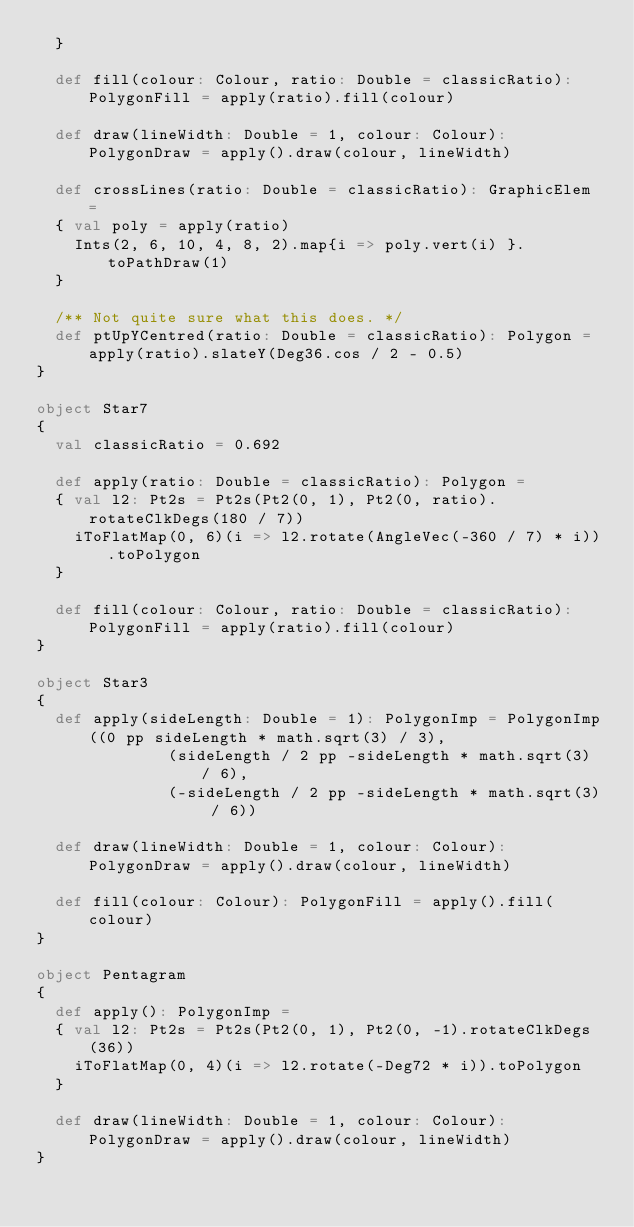<code> <loc_0><loc_0><loc_500><loc_500><_Scala_>  }

  def fill(colour: Colour, ratio: Double = classicRatio): PolygonFill = apply(ratio).fill(colour)
  
  def draw(lineWidth: Double = 1, colour: Colour): PolygonDraw = apply().draw(colour, lineWidth)

  def crossLines(ratio: Double = classicRatio): GraphicElem =
  { val poly = apply(ratio)
    Ints(2, 6, 10, 4, 8, 2).map{i => poly.vert(i) }.toPathDraw(1)
  }

  /** Not quite sure what this does. */
  def ptUpYCentred(ratio: Double = classicRatio): Polygon = apply(ratio).slateY(Deg36.cos / 2 - 0.5)
}

object Star7
{
  val classicRatio = 0.692

  def apply(ratio: Double = classicRatio): Polygon =
  { val l2: Pt2s = Pt2s(Pt2(0, 1), Pt2(0, ratio).rotateClkDegs(180 / 7))
    iToFlatMap(0, 6)(i => l2.rotate(AngleVec(-360 / 7) * i)).toPolygon
  }
  
  def fill(colour: Colour, ratio: Double = classicRatio): PolygonFill = apply(ratio).fill(colour)
}

object Star3
{
  def apply(sideLength: Double = 1): PolygonImp = PolygonImp((0 pp sideLength * math.sqrt(3) / 3),
              (sideLength / 2 pp -sideLength * math.sqrt(3) / 6),
              (-sideLength / 2 pp -sideLength * math.sqrt(3) / 6))
      
  def draw(lineWidth: Double = 1, colour: Colour): PolygonDraw = apply().draw(colour, lineWidth)

  def fill(colour: Colour): PolygonFill = apply().fill(colour)
}

object Pentagram
{
  def apply(): PolygonImp =
  { val l2: Pt2s = Pt2s(Pt2(0, 1), Pt2(0, -1).rotateClkDegs(36))
    iToFlatMap(0, 4)(i => l2.rotate(-Deg72 * i)).toPolygon
  }

  def draw(lineWidth: Double = 1, colour: Colour): PolygonDraw = apply().draw(colour, lineWidth)
}</code> 